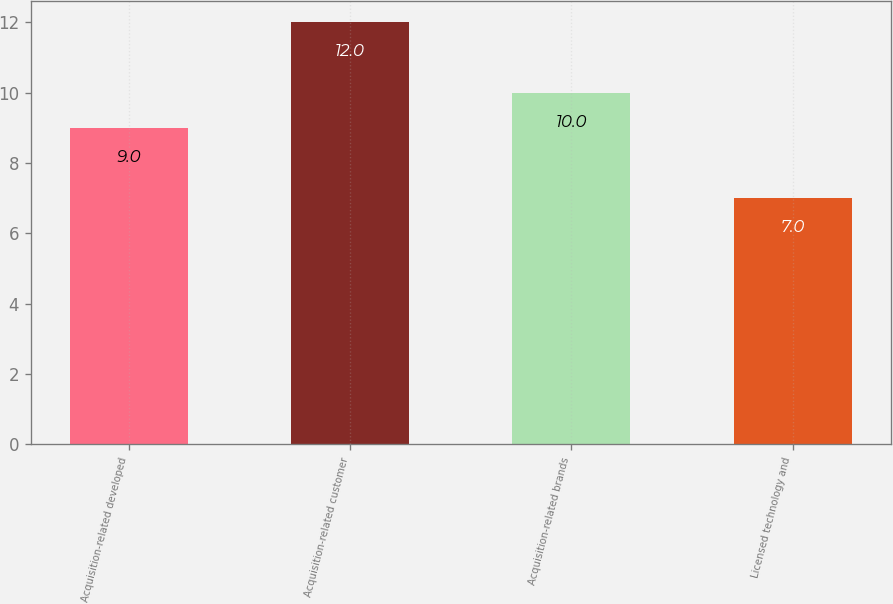Convert chart to OTSL. <chart><loc_0><loc_0><loc_500><loc_500><bar_chart><fcel>Acquisition-related developed<fcel>Acquisition-related customer<fcel>Acquisition-related brands<fcel>Licensed technology and<nl><fcel>9<fcel>12<fcel>10<fcel>7<nl></chart> 